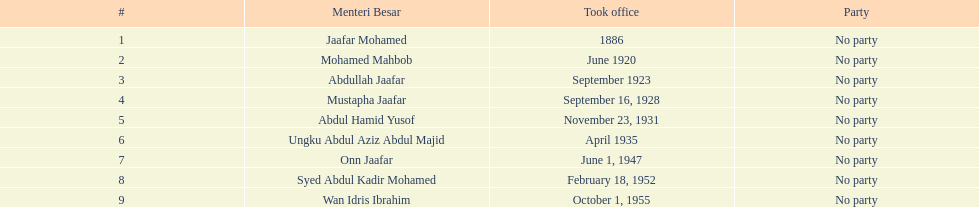How many years was jaafar mohamed in office? 4. 